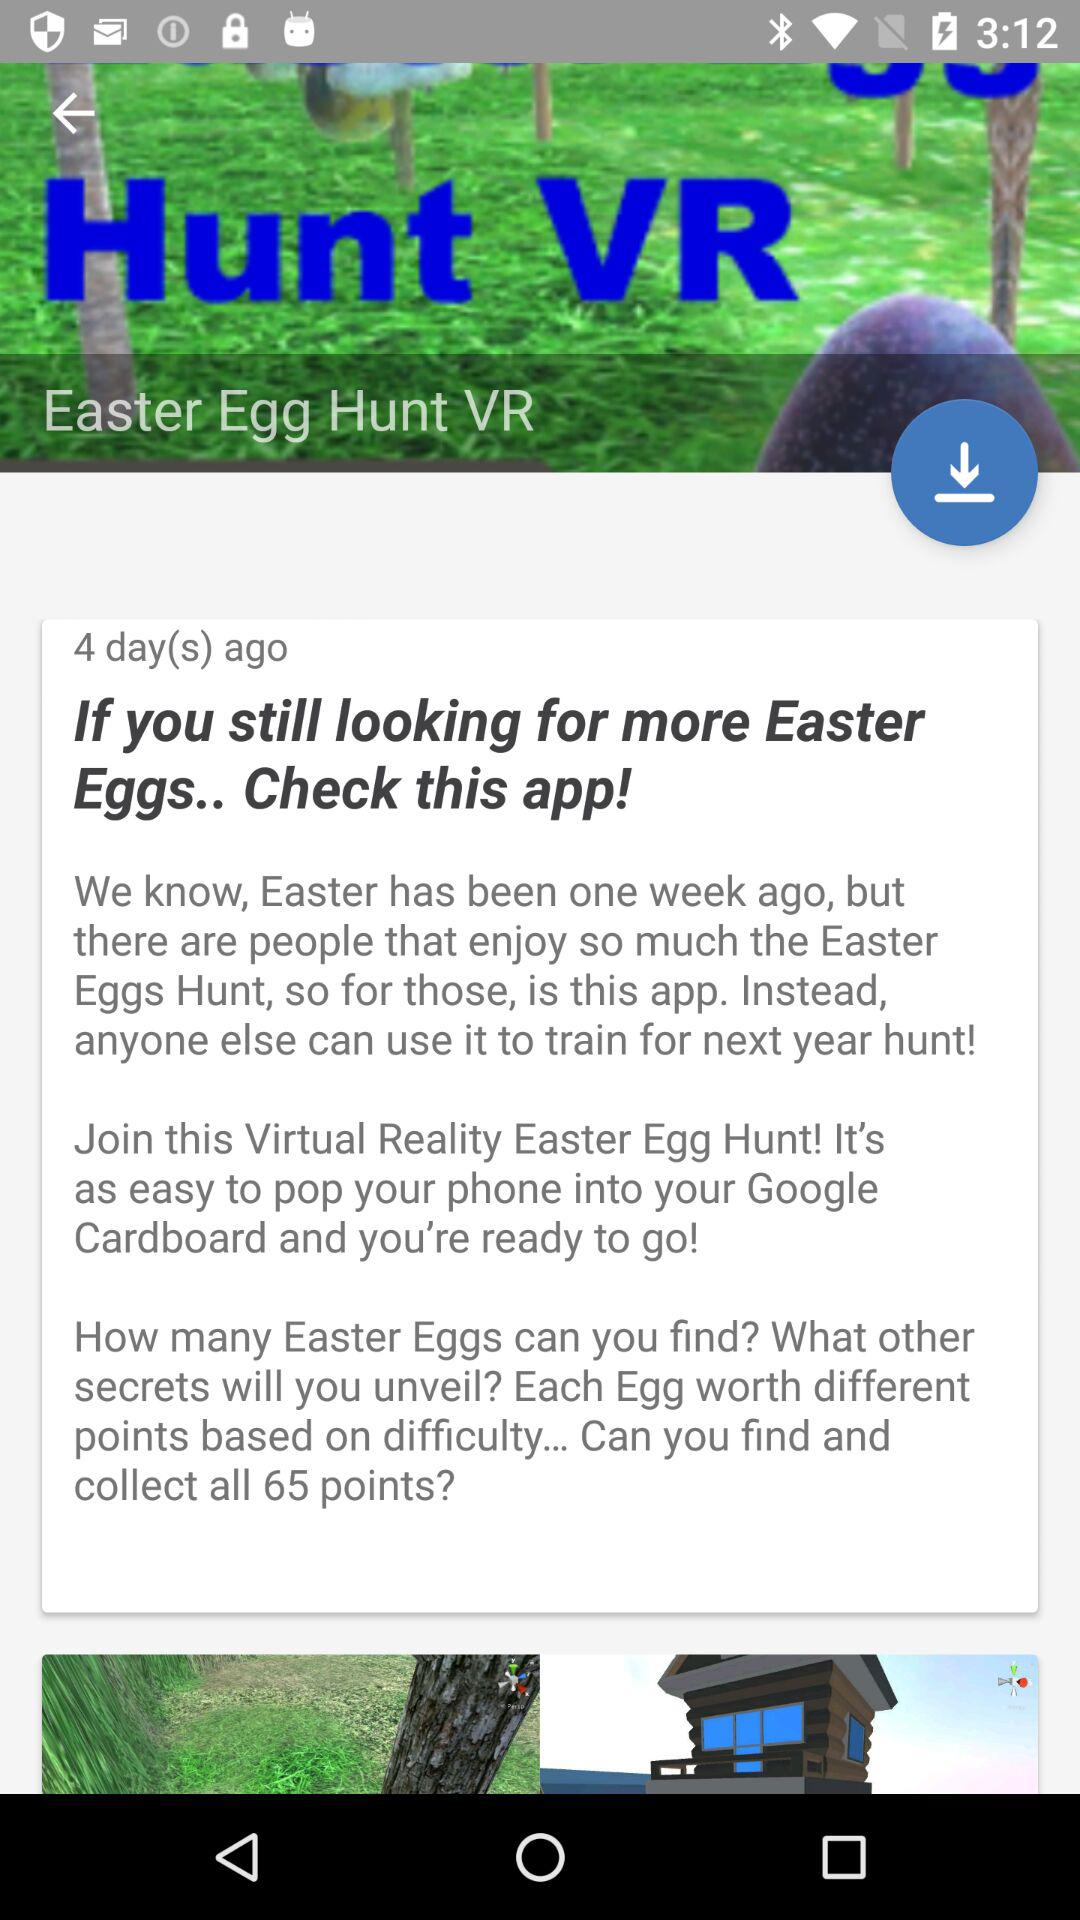How many Easter Eggs can you collect?
Answer the question using a single word or phrase. 65 